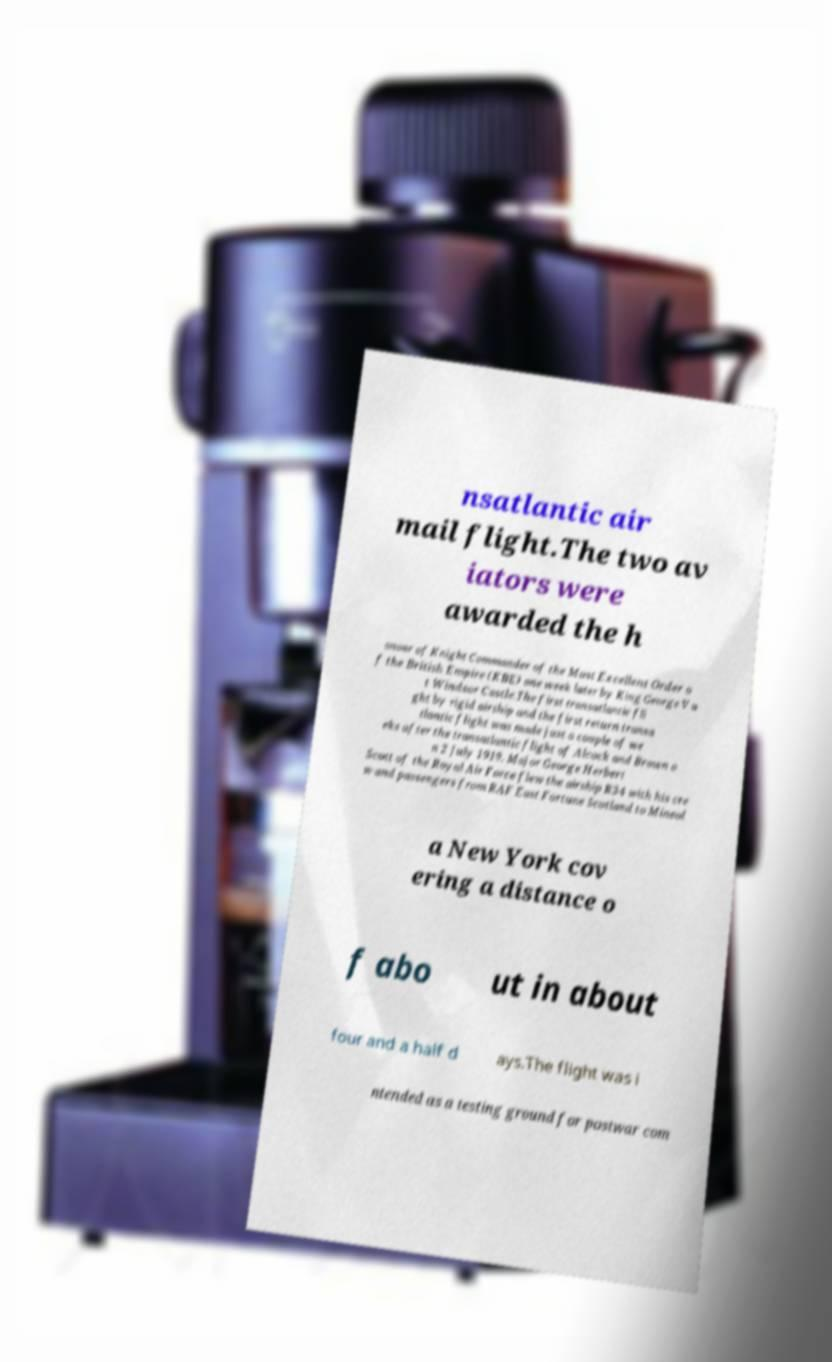Please read and relay the text visible in this image. What does it say? nsatlantic air mail flight.The two av iators were awarded the h onour of Knight Commander of the Most Excellent Order o f the British Empire (KBE) one week later by King George V a t Windsor Castle.The first transatlantic fli ght by rigid airship and the first return transa tlantic flight was made just a couple of we eks after the transatlantic flight of Alcock and Brown o n 2 July 1919. Major George Herbert Scott of the Royal Air Force flew the airship R34 with his cre w and passengers from RAF East Fortune Scotland to Mineol a New York cov ering a distance o f abo ut in about four and a half d ays.The flight was i ntended as a testing ground for postwar com 